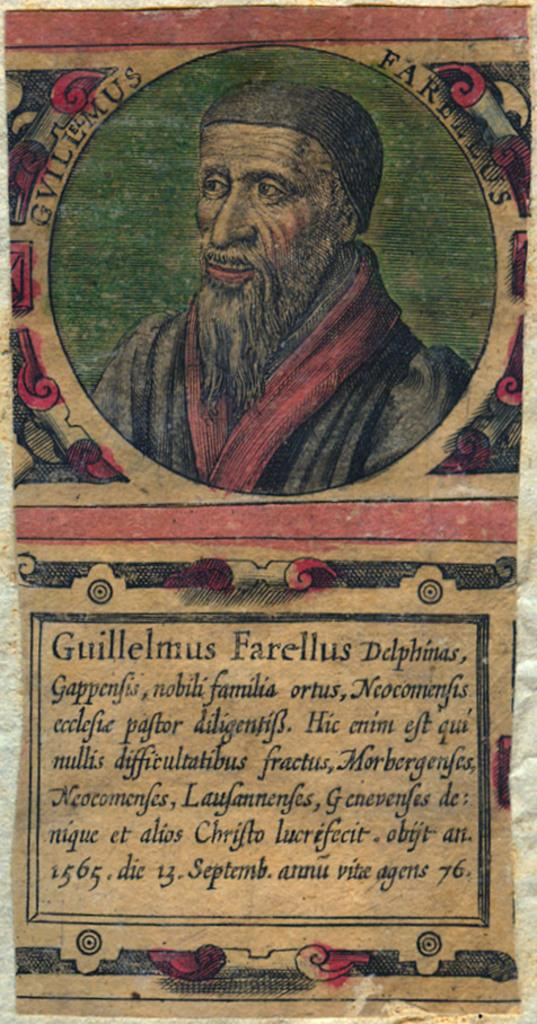What is present in the image related to advertising or promotion? There is a poster in the image. What can be seen on the poster? The poster has a man's image on it. What additional information is provided on the poster about the man? There is information about the man under his image on the poster. What type of quince is being used as a prop in the image? There is no quince present in the image; it only features a poster with a man's image and related information. 